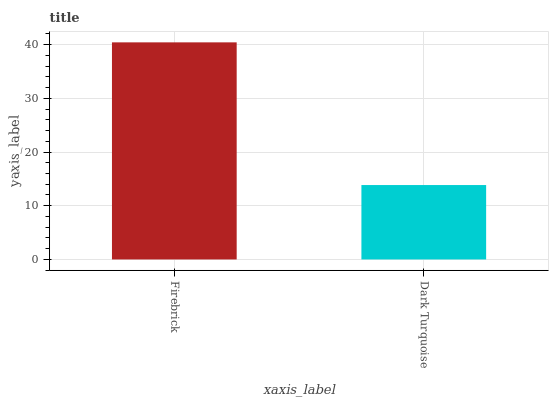Is Dark Turquoise the minimum?
Answer yes or no. Yes. Is Firebrick the maximum?
Answer yes or no. Yes. Is Dark Turquoise the maximum?
Answer yes or no. No. Is Firebrick greater than Dark Turquoise?
Answer yes or no. Yes. Is Dark Turquoise less than Firebrick?
Answer yes or no. Yes. Is Dark Turquoise greater than Firebrick?
Answer yes or no. No. Is Firebrick less than Dark Turquoise?
Answer yes or no. No. Is Firebrick the high median?
Answer yes or no. Yes. Is Dark Turquoise the low median?
Answer yes or no. Yes. Is Dark Turquoise the high median?
Answer yes or no. No. Is Firebrick the low median?
Answer yes or no. No. 